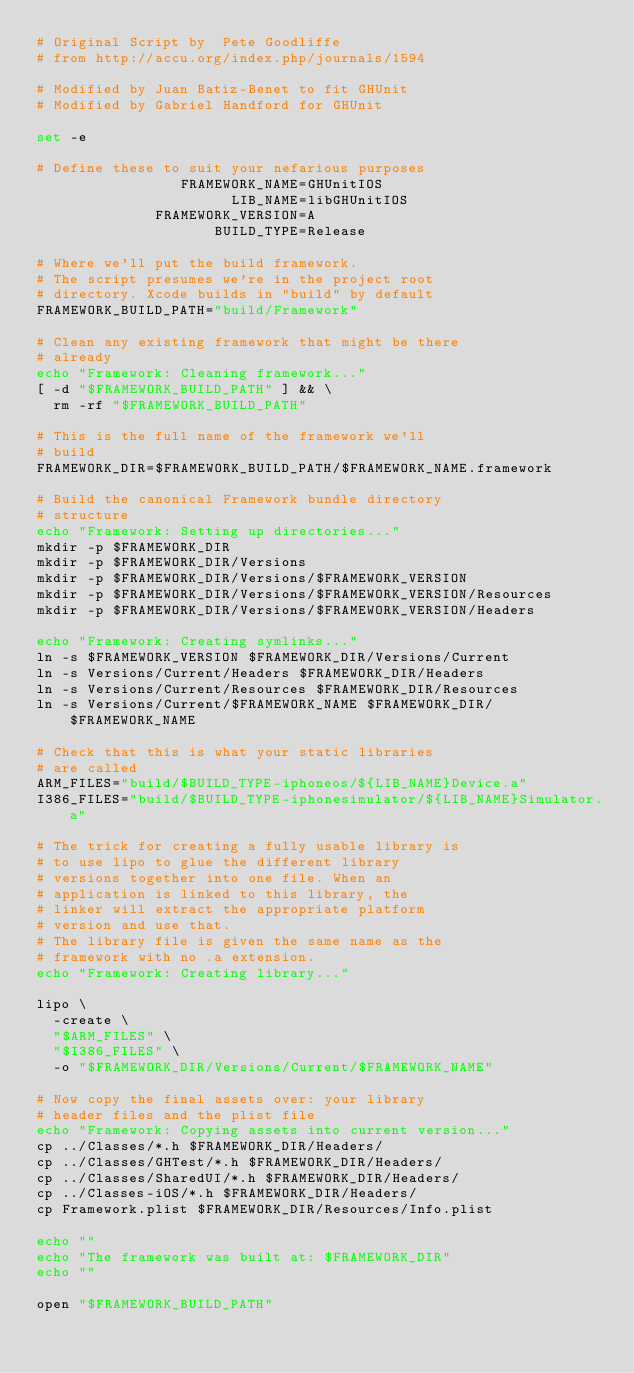<code> <loc_0><loc_0><loc_500><loc_500><_Bash_># Original Script by  Pete Goodliffe
# from http://accu.org/index.php/journals/1594

# Modified by Juan Batiz-Benet to fit GHUnit
# Modified by Gabriel Handford for GHUnit

set -e

# Define these to suit your nefarious purposes
                 FRAMEWORK_NAME=GHUnitIOS
                       LIB_NAME=libGHUnitIOS
              FRAMEWORK_VERSION=A
                     BUILD_TYPE=Release

# Where we'll put the build framework.
# The script presumes we're in the project root
# directory. Xcode builds in "build" by default
FRAMEWORK_BUILD_PATH="build/Framework"

# Clean any existing framework that might be there
# already
echo "Framework: Cleaning framework..."
[ -d "$FRAMEWORK_BUILD_PATH" ] && \
  rm -rf "$FRAMEWORK_BUILD_PATH"

# This is the full name of the framework we'll
# build
FRAMEWORK_DIR=$FRAMEWORK_BUILD_PATH/$FRAMEWORK_NAME.framework

# Build the canonical Framework bundle directory
# structure
echo "Framework: Setting up directories..."
mkdir -p $FRAMEWORK_DIR
mkdir -p $FRAMEWORK_DIR/Versions
mkdir -p $FRAMEWORK_DIR/Versions/$FRAMEWORK_VERSION
mkdir -p $FRAMEWORK_DIR/Versions/$FRAMEWORK_VERSION/Resources
mkdir -p $FRAMEWORK_DIR/Versions/$FRAMEWORK_VERSION/Headers

echo "Framework: Creating symlinks..."
ln -s $FRAMEWORK_VERSION $FRAMEWORK_DIR/Versions/Current
ln -s Versions/Current/Headers $FRAMEWORK_DIR/Headers
ln -s Versions/Current/Resources $FRAMEWORK_DIR/Resources
ln -s Versions/Current/$FRAMEWORK_NAME $FRAMEWORK_DIR/$FRAMEWORK_NAME

# Check that this is what your static libraries
# are called
ARM_FILES="build/$BUILD_TYPE-iphoneos/${LIB_NAME}Device.a"
I386_FILES="build/$BUILD_TYPE-iphonesimulator/${LIB_NAME}Simulator.a"

# The trick for creating a fully usable library is
# to use lipo to glue the different library
# versions together into one file. When an
# application is linked to this library, the
# linker will extract the appropriate platform
# version and use that.
# The library file is given the same name as the
# framework with no .a extension.
echo "Framework: Creating library..."

lipo \
  -create \
  "$ARM_FILES" \
  "$I386_FILES" \
  -o "$FRAMEWORK_DIR/Versions/Current/$FRAMEWORK_NAME"

# Now copy the final assets over: your library
# header files and the plist file
echo "Framework: Copying assets into current version..."
cp ../Classes/*.h $FRAMEWORK_DIR/Headers/
cp ../Classes/GHTest/*.h $FRAMEWORK_DIR/Headers/
cp ../Classes/SharedUI/*.h $FRAMEWORK_DIR/Headers/
cp ../Classes-iOS/*.h $FRAMEWORK_DIR/Headers/
cp Framework.plist $FRAMEWORK_DIR/Resources/Info.plist

echo ""
echo "The framework was built at: $FRAMEWORK_DIR"
echo ""

open "$FRAMEWORK_BUILD_PATH"
</code> 